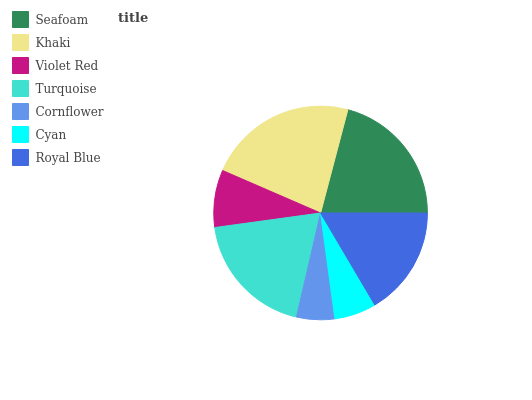Is Cornflower the minimum?
Answer yes or no. Yes. Is Khaki the maximum?
Answer yes or no. Yes. Is Violet Red the minimum?
Answer yes or no. No. Is Violet Red the maximum?
Answer yes or no. No. Is Khaki greater than Violet Red?
Answer yes or no. Yes. Is Violet Red less than Khaki?
Answer yes or no. Yes. Is Violet Red greater than Khaki?
Answer yes or no. No. Is Khaki less than Violet Red?
Answer yes or no. No. Is Royal Blue the high median?
Answer yes or no. Yes. Is Royal Blue the low median?
Answer yes or no. Yes. Is Cyan the high median?
Answer yes or no. No. Is Turquoise the low median?
Answer yes or no. No. 